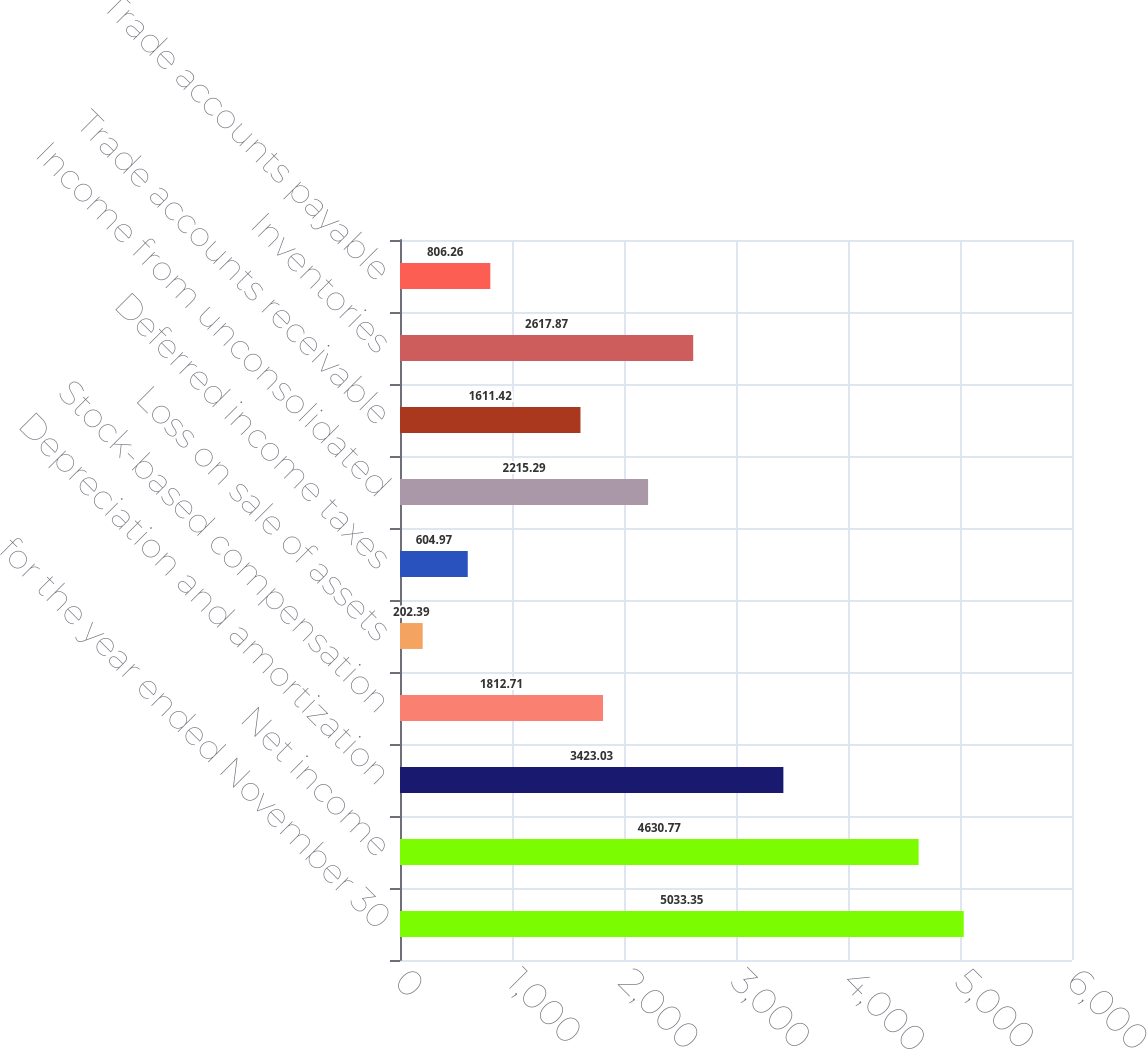Convert chart. <chart><loc_0><loc_0><loc_500><loc_500><bar_chart><fcel>for the year ended November 30<fcel>Net income<fcel>Depreciation and amortization<fcel>Stock-based compensation<fcel>Loss on sale of assets<fcel>Deferred income taxes<fcel>Income from unconsolidated<fcel>Trade accounts receivable<fcel>Inventories<fcel>Trade accounts payable<nl><fcel>5033.35<fcel>4630.77<fcel>3423.03<fcel>1812.71<fcel>202.39<fcel>604.97<fcel>2215.29<fcel>1611.42<fcel>2617.87<fcel>806.26<nl></chart> 